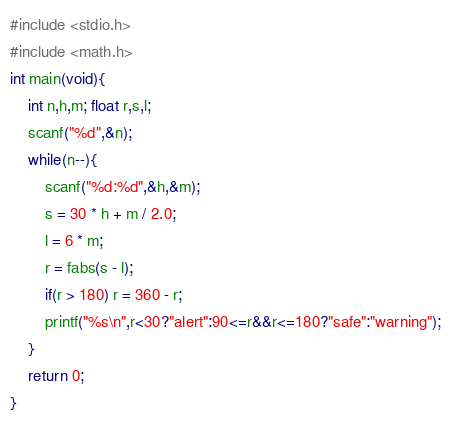Convert code to text. <code><loc_0><loc_0><loc_500><loc_500><_C_>#include <stdio.h>
#include <math.h>
int main(void){
	int n,h,m; float r,s,l;
	scanf("%d",&n);
	while(n--){
		scanf("%d:%d",&h,&m);
		s = 30 * h + m / 2.0;
		l = 6 * m;
		r = fabs(s - l);
		if(r > 180) r = 360 - r;
		printf("%s\n",r<30?"alert":90<=r&&r<=180?"safe":"warning");
	}
	return 0;
}</code> 